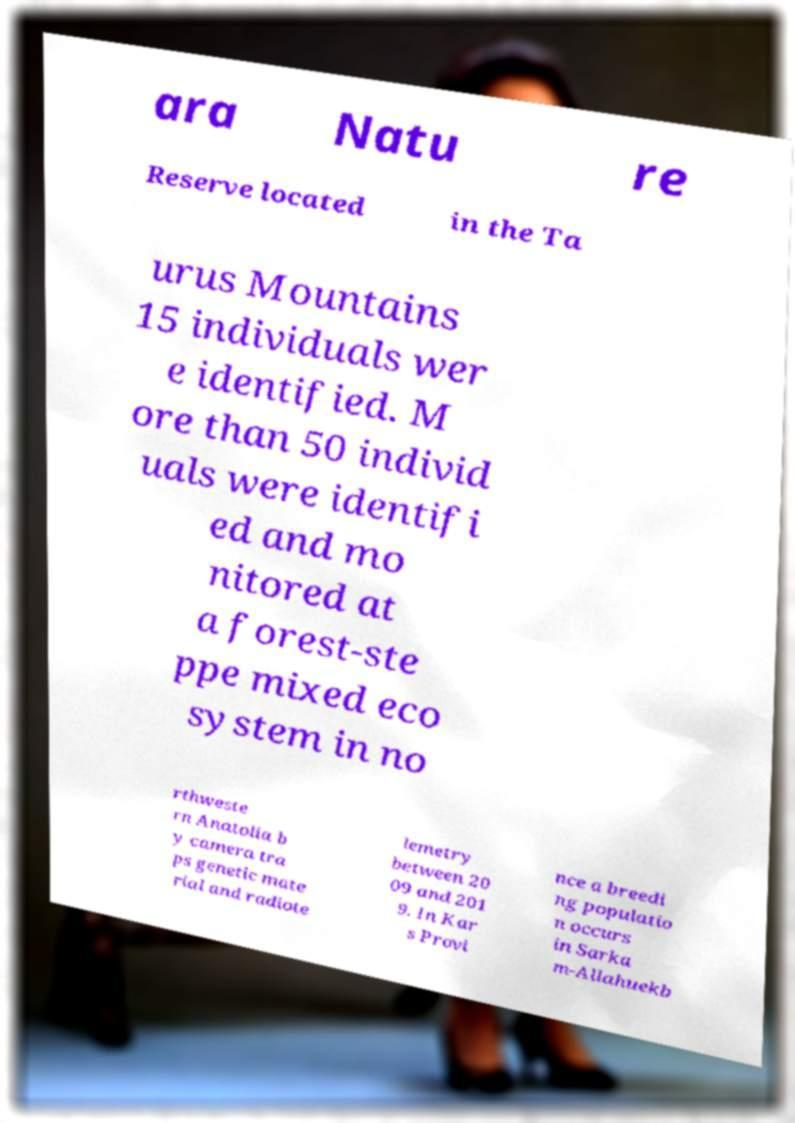I need the written content from this picture converted into text. Can you do that? ara Natu re Reserve located in the Ta urus Mountains 15 individuals wer e identified. M ore than 50 individ uals were identifi ed and mo nitored at a forest-ste ppe mixed eco system in no rthweste rn Anatolia b y camera tra ps genetic mate rial and radiote lemetry between 20 09 and 201 9. In Kar s Provi nce a breedi ng populatio n occurs in Sarka m-Allahuekb 